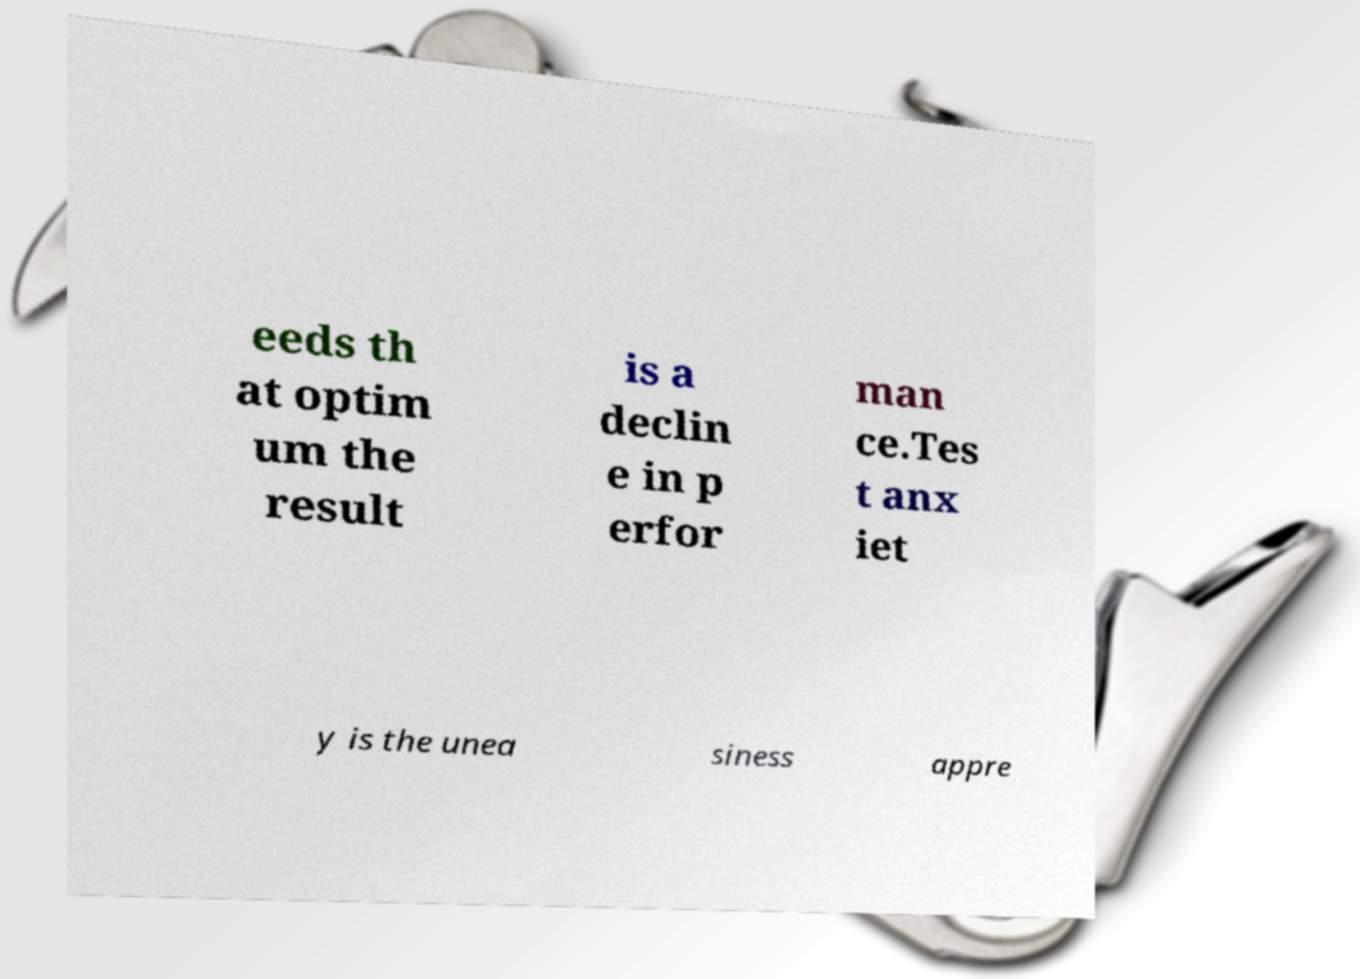For documentation purposes, I need the text within this image transcribed. Could you provide that? eeds th at optim um the result is a declin e in p erfor man ce.Tes t anx iet y is the unea siness appre 